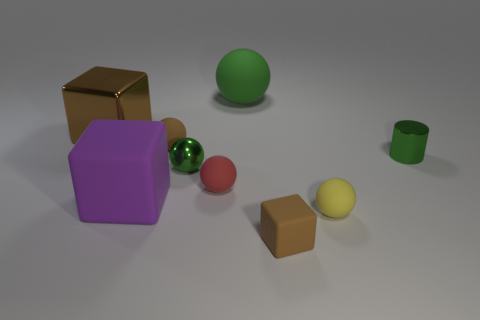Subtract all large green spheres. How many spheres are left? 4 Subtract all brown blocks. How many blocks are left? 1 Subtract all brown matte balls. Subtract all green rubber balls. How many objects are left? 7 Add 8 small green metal cylinders. How many small green metal cylinders are left? 9 Add 5 small rubber balls. How many small rubber balls exist? 8 Subtract 1 yellow spheres. How many objects are left? 8 Subtract all blocks. How many objects are left? 6 Subtract 1 cylinders. How many cylinders are left? 0 Subtract all blue spheres. Subtract all green cubes. How many spheres are left? 5 Subtract all cyan cylinders. How many brown balls are left? 1 